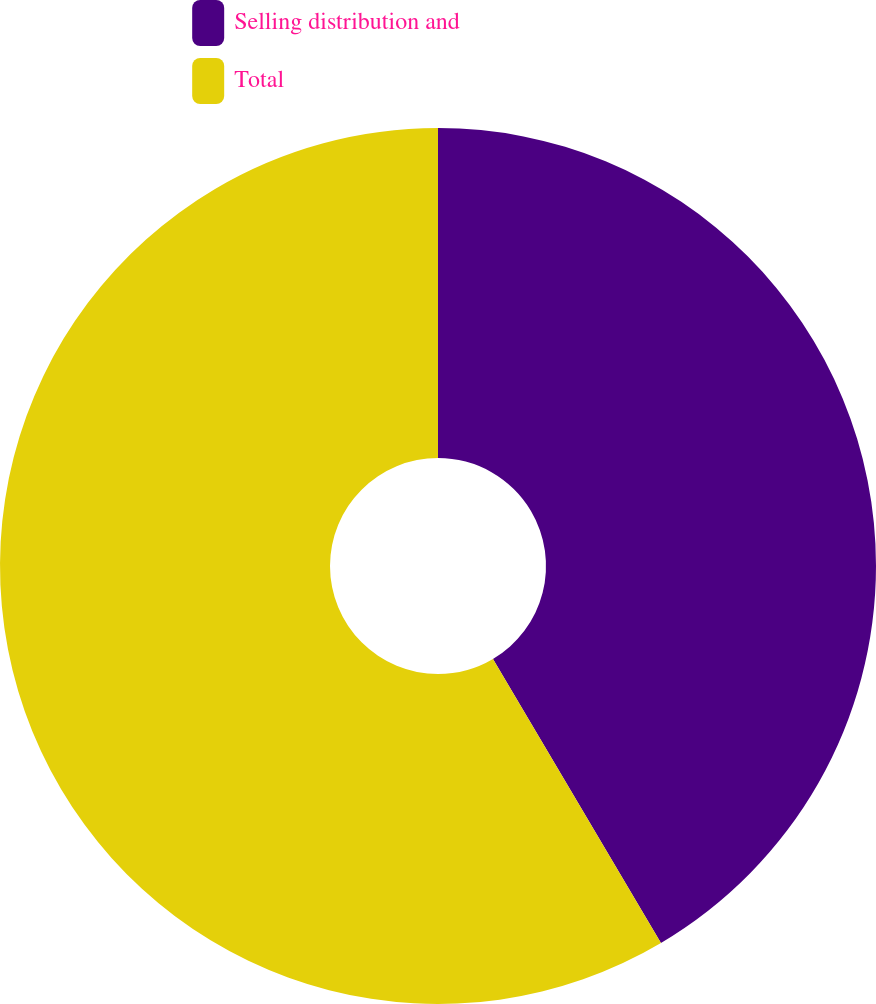Convert chart to OTSL. <chart><loc_0><loc_0><loc_500><loc_500><pie_chart><fcel>Selling distribution and<fcel>Total<nl><fcel>41.5%<fcel>58.5%<nl></chart> 